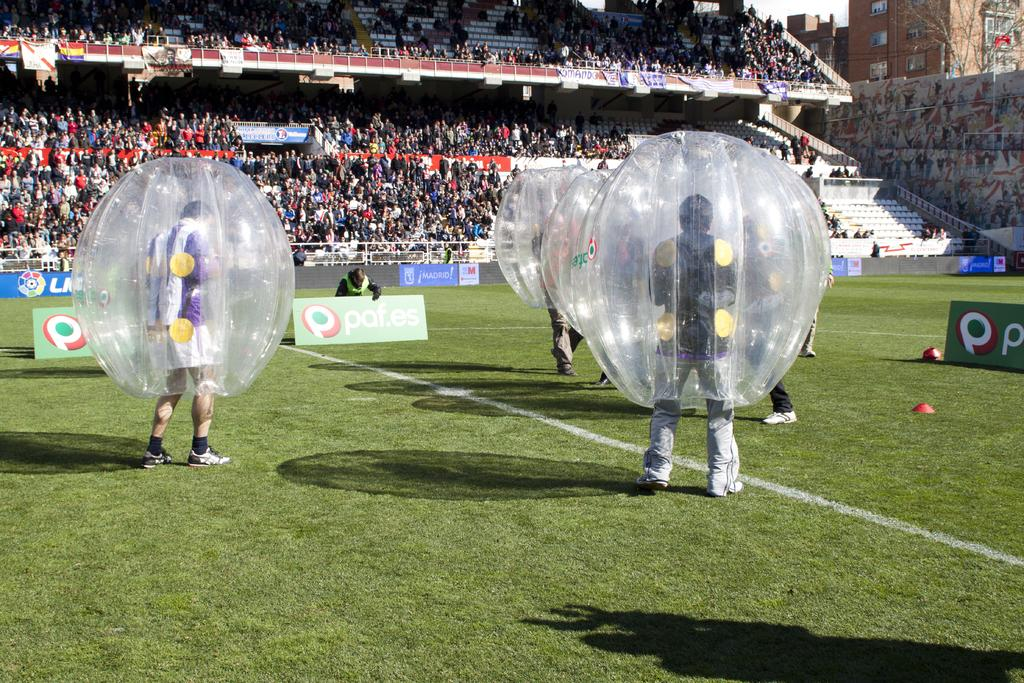What are the people wearing in the image? The people are wearing inflatable suits in the image. Where are the people standing? The people are standing on the grass in the image. What is the location of the scene? The scene takes place inside a stadium. Can you describe the presence of other people in the image? There are spectators in the background of the image. What is the value of the cart in the image? There is no cart present in the image, so it is not possible to determine its value. 